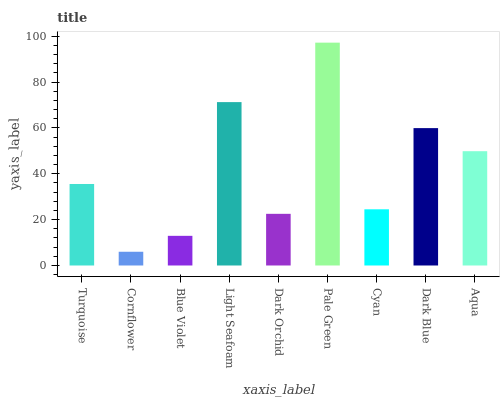Is Cornflower the minimum?
Answer yes or no. Yes. Is Pale Green the maximum?
Answer yes or no. Yes. Is Blue Violet the minimum?
Answer yes or no. No. Is Blue Violet the maximum?
Answer yes or no. No. Is Blue Violet greater than Cornflower?
Answer yes or no. Yes. Is Cornflower less than Blue Violet?
Answer yes or no. Yes. Is Cornflower greater than Blue Violet?
Answer yes or no. No. Is Blue Violet less than Cornflower?
Answer yes or no. No. Is Turquoise the high median?
Answer yes or no. Yes. Is Turquoise the low median?
Answer yes or no. Yes. Is Dark Orchid the high median?
Answer yes or no. No. Is Blue Violet the low median?
Answer yes or no. No. 